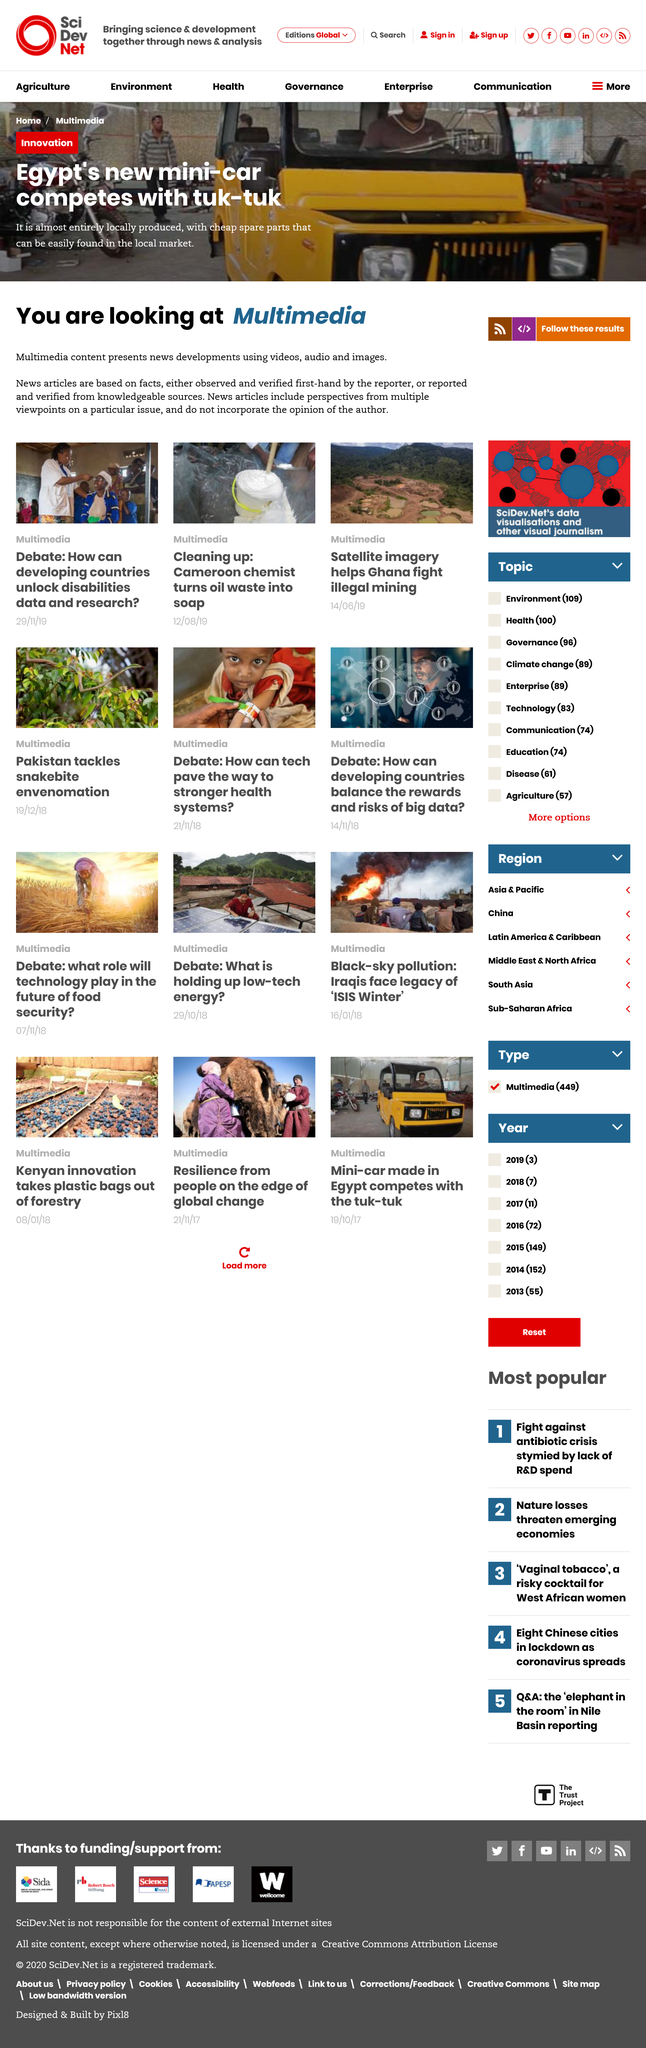Give some essential details in this illustration. News articles do not incorporate the opinion of the author. Multimedia is a type of digital content that incorporates various forms of media, such as videos, audio, and images, to present information or tell a story. This content has become increasingly popular due to the advancements in technology and the abundance of devices that can access and display it. Egypt's new mini-car is produced using locally sourced materials and affordable spare parts that are easily accessible in the local market, demonstrating our commitment to promoting sustainable and cost-effective manufacturing practices. 